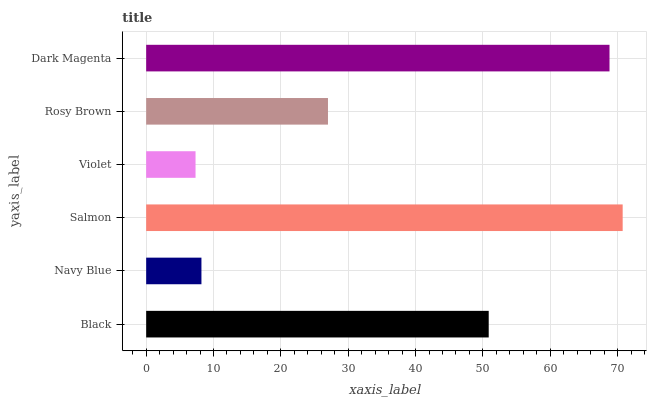Is Violet the minimum?
Answer yes or no. Yes. Is Salmon the maximum?
Answer yes or no. Yes. Is Navy Blue the minimum?
Answer yes or no. No. Is Navy Blue the maximum?
Answer yes or no. No. Is Black greater than Navy Blue?
Answer yes or no. Yes. Is Navy Blue less than Black?
Answer yes or no. Yes. Is Navy Blue greater than Black?
Answer yes or no. No. Is Black less than Navy Blue?
Answer yes or no. No. Is Black the high median?
Answer yes or no. Yes. Is Rosy Brown the low median?
Answer yes or no. Yes. Is Navy Blue the high median?
Answer yes or no. No. Is Navy Blue the low median?
Answer yes or no. No. 